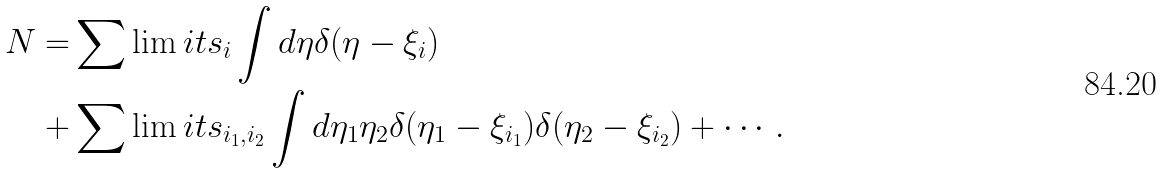Convert formula to latex. <formula><loc_0><loc_0><loc_500><loc_500>N = & \sum \lim i t s _ { i } \int d \eta \delta ( \eta - \xi _ { i } ) \\ + & \sum \lim i t s _ { i _ { 1 } , i _ { 2 } } \int d \eta _ { 1 } \eta _ { 2 } \delta ( \eta _ { 1 } - \xi _ { i _ { 1 } } ) \delta ( \eta _ { 2 } - \xi _ { i _ { 2 } } ) + \cdots .</formula> 